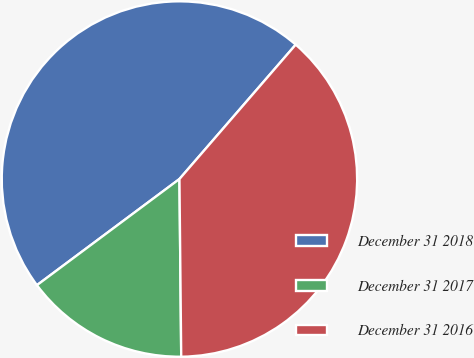<chart> <loc_0><loc_0><loc_500><loc_500><pie_chart><fcel>December 31 2018<fcel>December 31 2017<fcel>December 31 2016<nl><fcel>46.54%<fcel>14.97%<fcel>38.49%<nl></chart> 